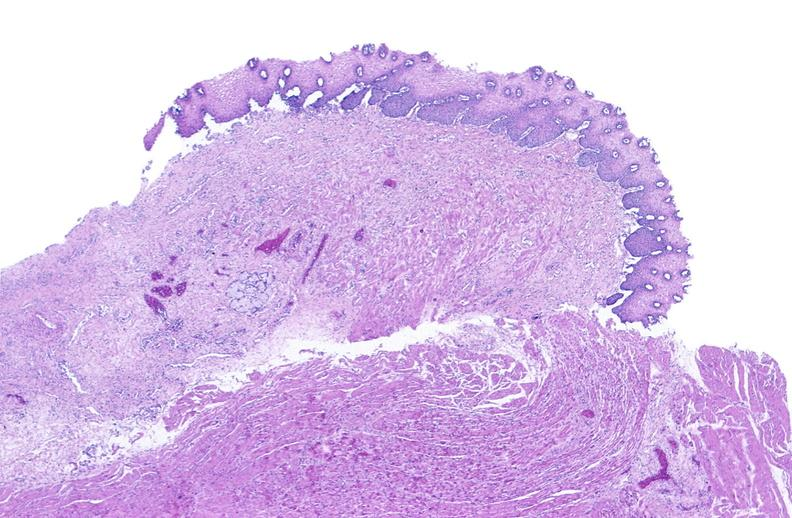does gout show esophagus?
Answer the question using a single word or phrase. No 